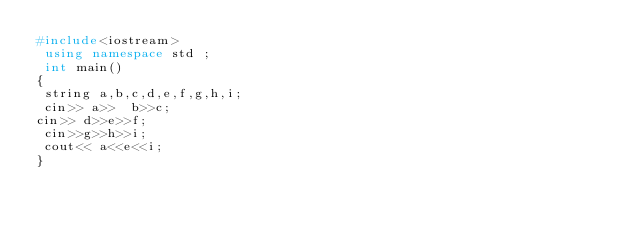Convert code to text. <code><loc_0><loc_0><loc_500><loc_500><_C++_>#include<iostream>
 using namespace std ;
 int main()
{
 string a,b,c,d,e,f,g,h,i;
 cin>> a>>  b>>c;
cin>> d>>e>>f;
 cin>>g>>h>>i;
 cout<< a<<e<<i;
}</code> 